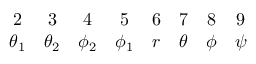<formula> <loc_0><loc_0><loc_500><loc_500>\begin{array} { c c c c c c c c } { 2 } & { 3 } & { 4 } & { 5 } & { 6 } & { 7 } & { 8 } & { 9 } \\ { { \theta _ { 1 } } } & { { \theta _ { 2 } } } & { { \phi _ { 2 } } } & { { \phi _ { 1 } } } & { r } & { \theta } & { \phi } & { \psi } \end{array}</formula> 